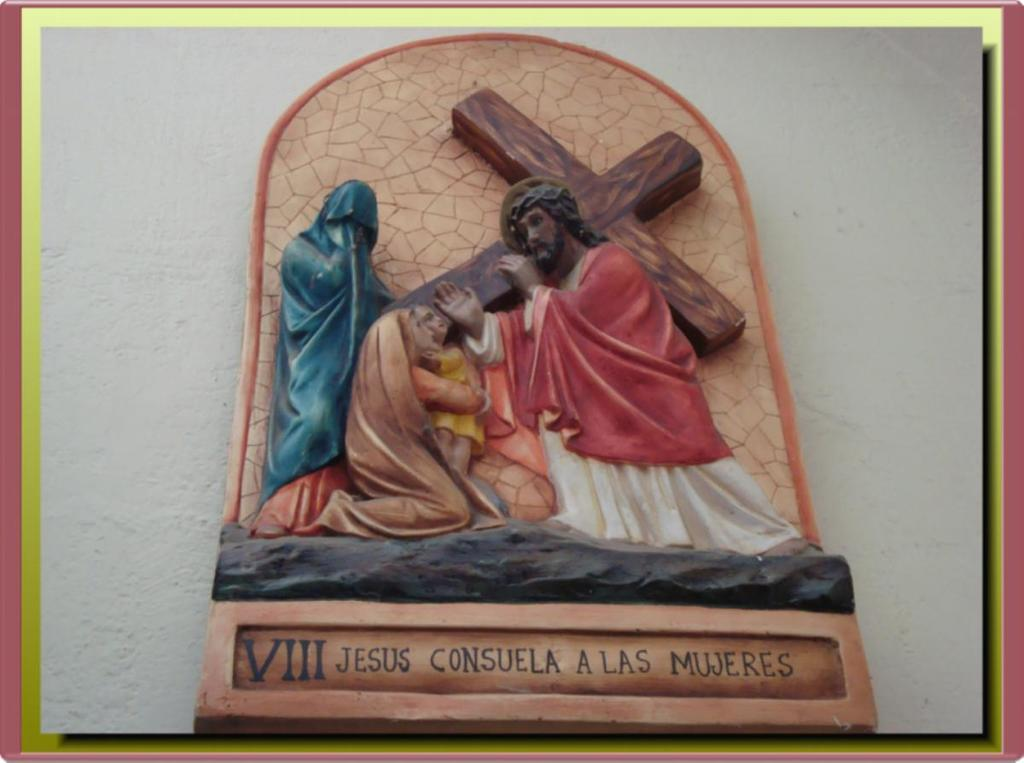Provide a one-sentence caption for the provided image. A statue has the roman numeral VIII on the bottom. 